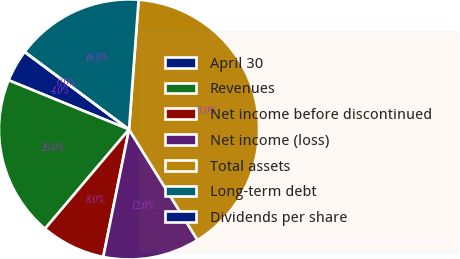Convert chart. <chart><loc_0><loc_0><loc_500><loc_500><pie_chart><fcel>April 30<fcel>Revenues<fcel>Net income before discontinued<fcel>Net income (loss)<fcel>Total assets<fcel>Long-term debt<fcel>Dividends per share<nl><fcel>4.0%<fcel>20.0%<fcel>8.0%<fcel>12.0%<fcel>40.0%<fcel>16.0%<fcel>0.0%<nl></chart> 